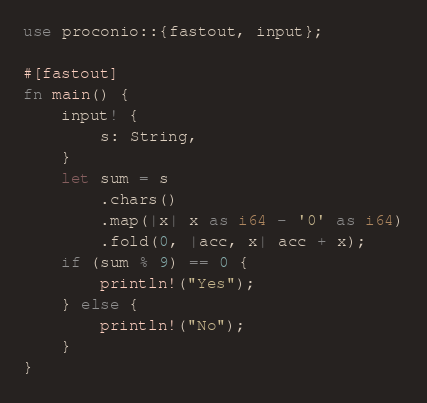<code> <loc_0><loc_0><loc_500><loc_500><_Rust_>use proconio::{fastout, input};

#[fastout]
fn main() {
    input! {
        s: String,
    }
    let sum = s
        .chars()
        .map(|x| x as i64 - '0' as i64)
        .fold(0, |acc, x| acc + x);
    if (sum % 9) == 0 {
        println!("Yes");
    } else {
        println!("No");
    }
}
</code> 